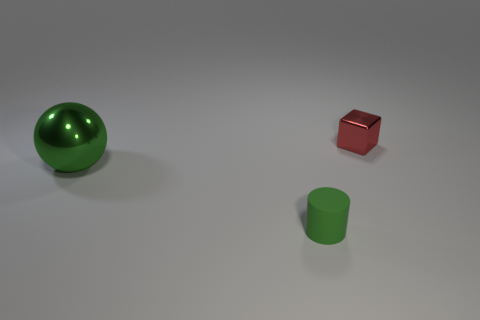What size is the other object that is the same color as the large object?
Your answer should be compact. Small. The metal ball has what size?
Make the answer very short. Large. Are there any other things that are the same color as the cylinder?
Offer a terse response. Yes. There is a green thing in front of the big thing; is its size the same as the metal object that is to the right of the large metallic thing?
Offer a very short reply. Yes. Is the number of balls behind the red object the same as the number of big objects that are on the left side of the tiny green thing?
Your answer should be very brief. No. There is a green cylinder; is its size the same as the object on the right side of the small rubber thing?
Your answer should be compact. Yes. Are there any metal blocks right of the shiny thing that is in front of the tiny cube?
Your answer should be compact. Yes. Is there a gray thing of the same shape as the small green matte object?
Your answer should be compact. No. How many green rubber objects are on the left side of the shiny object on the right side of the small thing that is to the left of the small red metal block?
Make the answer very short. 1. There is a large sphere; does it have the same color as the small thing in front of the red metal block?
Offer a terse response. Yes. 